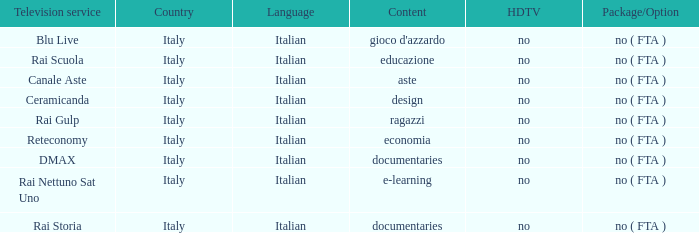What is the Language when the Reteconomy is the television service? Italian. 